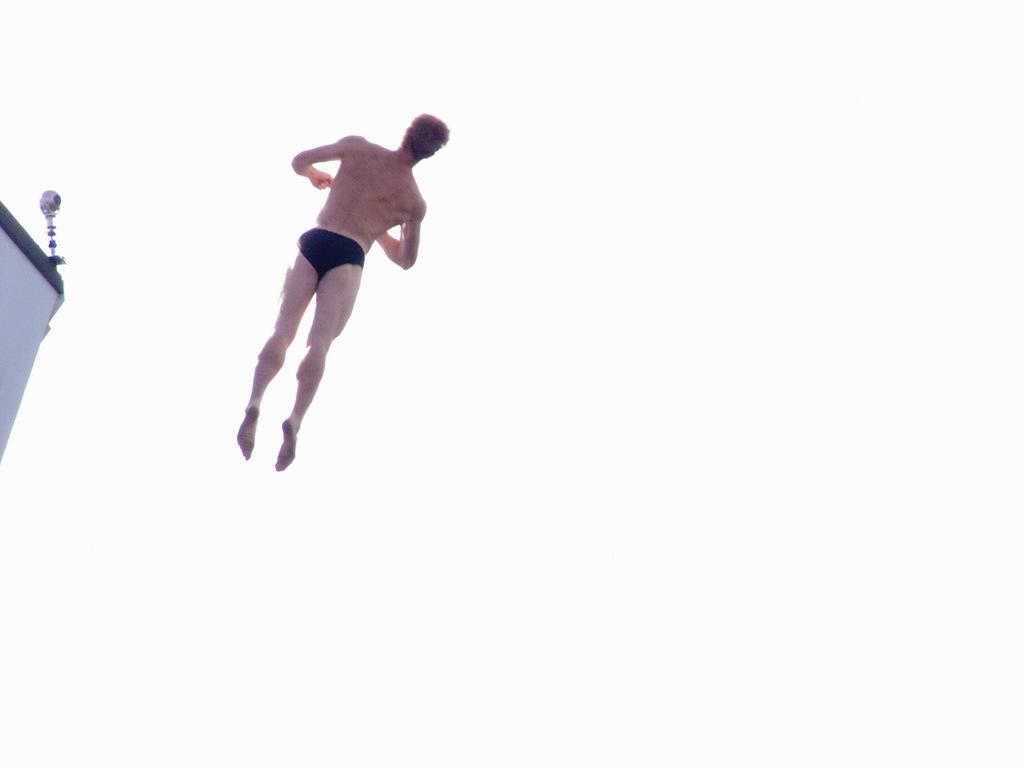What is the main subject of the image? There is a man in the image. What is the man wearing? The man is wearing black underwear. What action is the man performing in the image? The man is jumping from a building. What can be seen on the left side of the image? There is a pole on the corner of a wall on the left side of the image. What is visible in the background of the image? The sky is visible in the background of the image. How many babies are present in the image? There are no babies present in the image. What type of school is visible in the image? There is no school present in the image. 